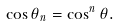Convert formula to latex. <formula><loc_0><loc_0><loc_500><loc_500>\cos \theta _ { n } = \cos ^ { n } \theta .</formula> 